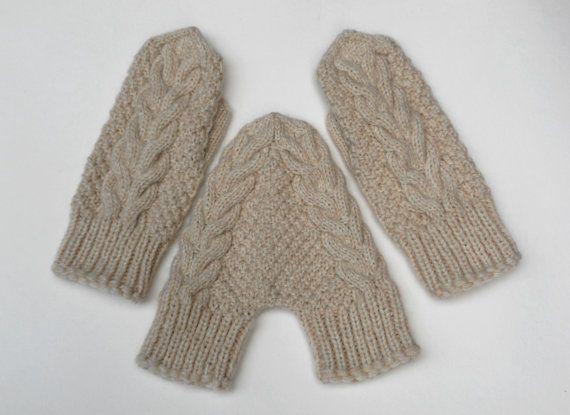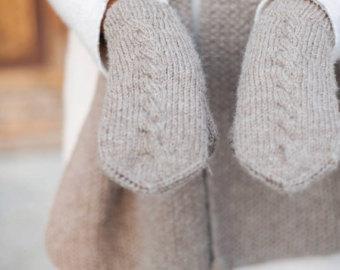The first image is the image on the left, the second image is the image on the right. Assess this claim about the two images: "The gloves in one of the images is not being worn.". Correct or not? Answer yes or no. Yes. The first image is the image on the left, the second image is the image on the right. For the images displayed, is the sentence "Each image shows exactly one pair of """"mittens"""", and one features a pair with a rounded flap and half-fingers." factually correct? Answer yes or no. No. 